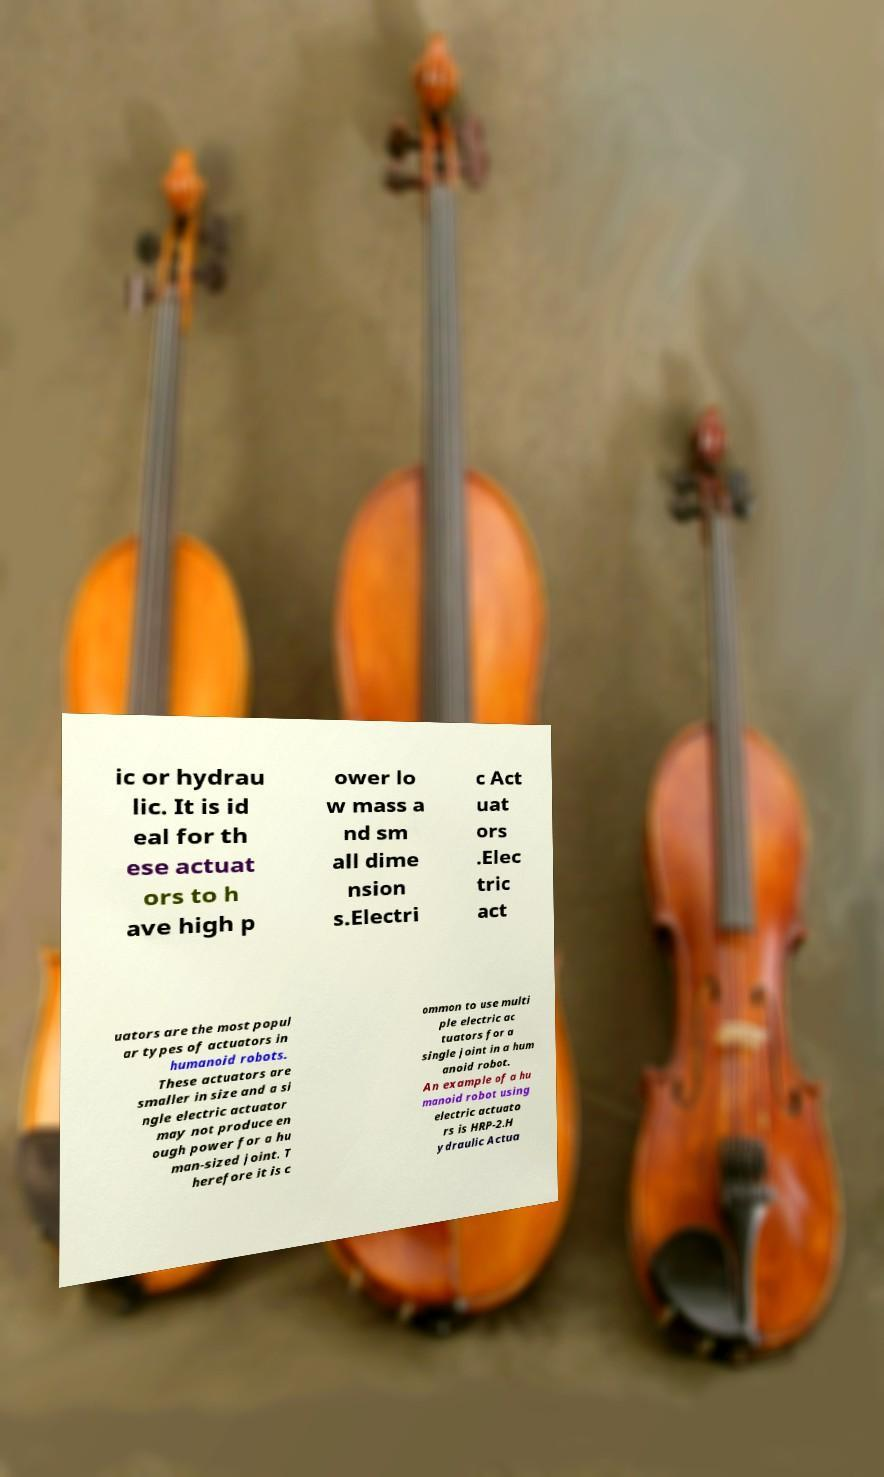I need the written content from this picture converted into text. Can you do that? ic or hydrau lic. It is id eal for th ese actuat ors to h ave high p ower lo w mass a nd sm all dime nsion s.Electri c Act uat ors .Elec tric act uators are the most popul ar types of actuators in humanoid robots. These actuators are smaller in size and a si ngle electric actuator may not produce en ough power for a hu man-sized joint. T herefore it is c ommon to use multi ple electric ac tuators for a single joint in a hum anoid robot. An example of a hu manoid robot using electric actuato rs is HRP-2.H ydraulic Actua 